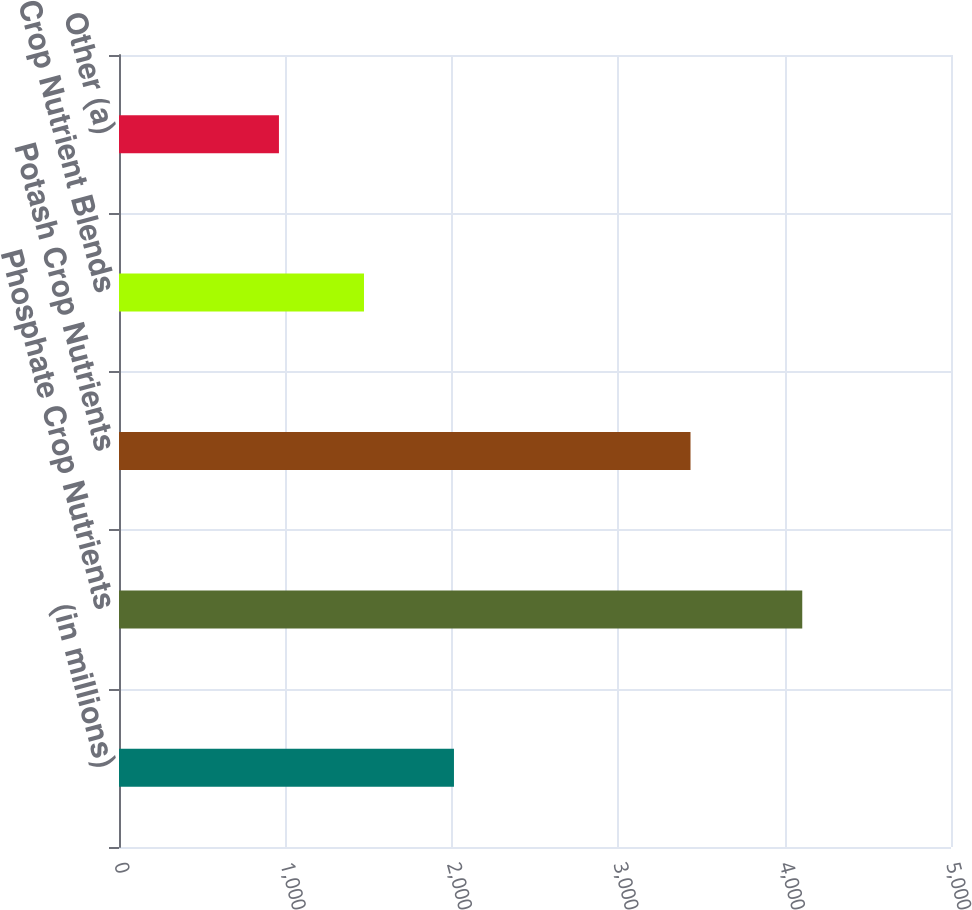Convert chart to OTSL. <chart><loc_0><loc_0><loc_500><loc_500><bar_chart><fcel>(in millions)<fcel>Phosphate Crop Nutrients<fcel>Potash Crop Nutrients<fcel>Crop Nutrient Blends<fcel>Other (a)<nl><fcel>2013<fcel>4106.1<fcel>3434.5<fcel>1472.3<fcel>961.2<nl></chart> 